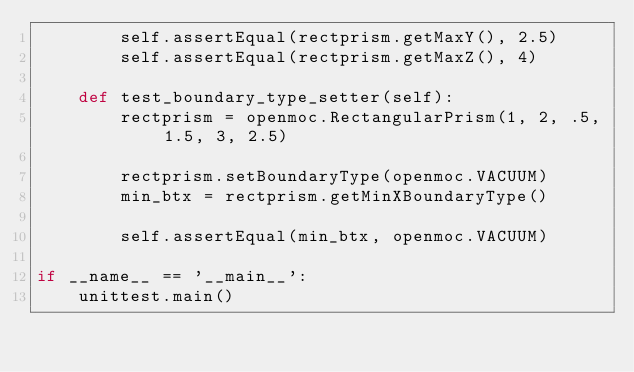<code> <loc_0><loc_0><loc_500><loc_500><_Python_>        self.assertEqual(rectprism.getMaxY(), 2.5)
        self.assertEqual(rectprism.getMaxZ(), 4)

    def test_boundary_type_setter(self):
        rectprism = openmoc.RectangularPrism(1, 2, .5, 1.5, 3, 2.5)

        rectprism.setBoundaryType(openmoc.VACUUM)
        min_btx = rectprism.getMinXBoundaryType()

        self.assertEqual(min_btx, openmoc.VACUUM)

if __name__ == '__main__':
    unittest.main()</code> 